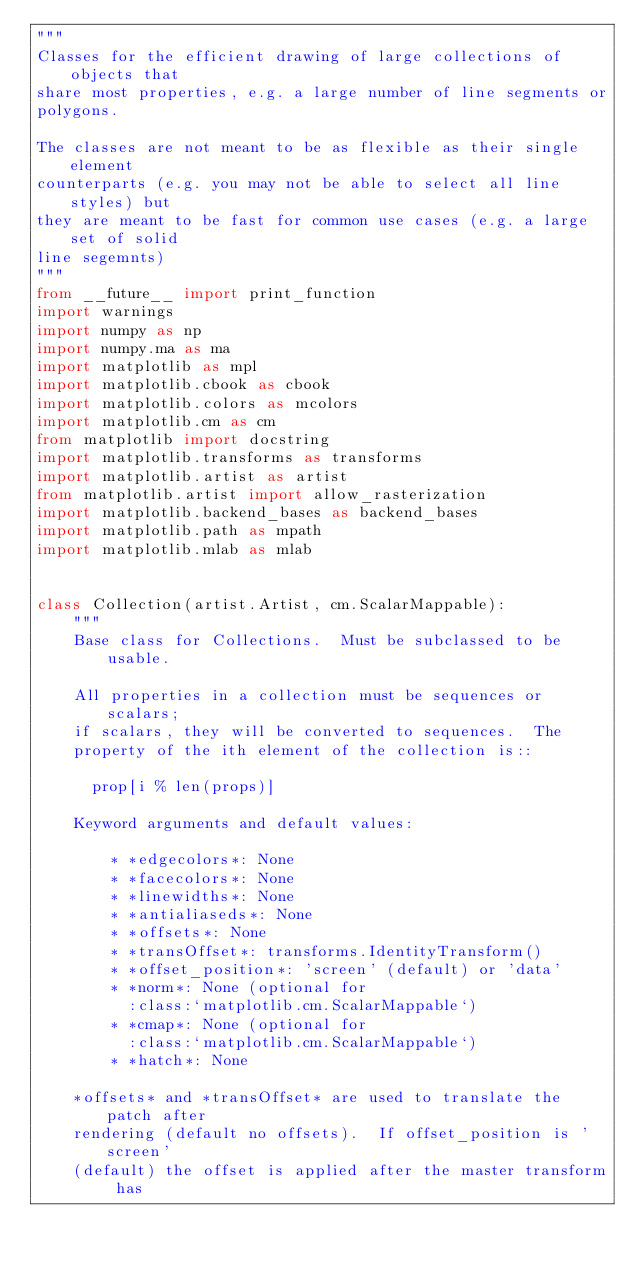<code> <loc_0><loc_0><loc_500><loc_500><_Python_>"""
Classes for the efficient drawing of large collections of objects that
share most properties, e.g. a large number of line segments or
polygons.

The classes are not meant to be as flexible as their single element
counterparts (e.g. you may not be able to select all line styles) but
they are meant to be fast for common use cases (e.g. a large set of solid
line segemnts)
"""
from __future__ import print_function
import warnings
import numpy as np
import numpy.ma as ma
import matplotlib as mpl
import matplotlib.cbook as cbook
import matplotlib.colors as mcolors
import matplotlib.cm as cm
from matplotlib import docstring
import matplotlib.transforms as transforms
import matplotlib.artist as artist
from matplotlib.artist import allow_rasterization
import matplotlib.backend_bases as backend_bases
import matplotlib.path as mpath
import matplotlib.mlab as mlab


class Collection(artist.Artist, cm.ScalarMappable):
    """
    Base class for Collections.  Must be subclassed to be usable.

    All properties in a collection must be sequences or scalars;
    if scalars, they will be converted to sequences.  The
    property of the ith element of the collection is::

      prop[i % len(props)]

    Keyword arguments and default values:

        * *edgecolors*: None
        * *facecolors*: None
        * *linewidths*: None
        * *antialiaseds*: None
        * *offsets*: None
        * *transOffset*: transforms.IdentityTransform()
        * *offset_position*: 'screen' (default) or 'data'
        * *norm*: None (optional for
          :class:`matplotlib.cm.ScalarMappable`)
        * *cmap*: None (optional for
          :class:`matplotlib.cm.ScalarMappable`)
        * *hatch*: None

    *offsets* and *transOffset* are used to translate the patch after
    rendering (default no offsets).  If offset_position is 'screen'
    (default) the offset is applied after the master transform has</code> 